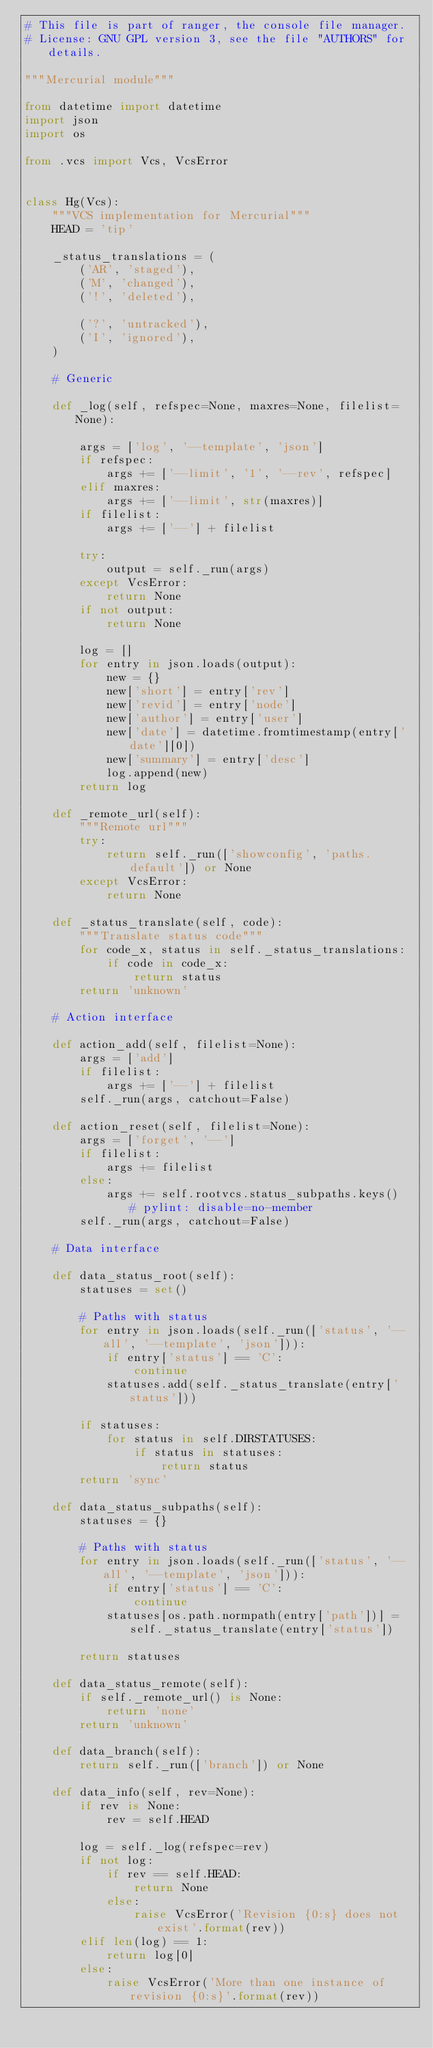Convert code to text. <code><loc_0><loc_0><loc_500><loc_500><_Python_># This file is part of ranger, the console file manager.
# License: GNU GPL version 3, see the file "AUTHORS" for details.

"""Mercurial module"""

from datetime import datetime
import json
import os

from .vcs import Vcs, VcsError


class Hg(Vcs):
    """VCS implementation for Mercurial"""
    HEAD = 'tip'

    _status_translations = (
        ('AR', 'staged'),
        ('M', 'changed'),
        ('!', 'deleted'),

        ('?', 'untracked'),
        ('I', 'ignored'),
    )

    # Generic

    def _log(self, refspec=None, maxres=None, filelist=None):

        args = ['log', '--template', 'json']
        if refspec:
            args += ['--limit', '1', '--rev', refspec]
        elif maxres:
            args += ['--limit', str(maxres)]
        if filelist:
            args += ['--'] + filelist

        try:
            output = self._run(args)
        except VcsError:
            return None
        if not output:
            return None

        log = []
        for entry in json.loads(output):
            new = {}
            new['short'] = entry['rev']
            new['revid'] = entry['node']
            new['author'] = entry['user']
            new['date'] = datetime.fromtimestamp(entry['date'][0])
            new['summary'] = entry['desc']
            log.append(new)
        return log

    def _remote_url(self):
        """Remote url"""
        try:
            return self._run(['showconfig', 'paths.default']) or None
        except VcsError:
            return None

    def _status_translate(self, code):
        """Translate status code"""
        for code_x, status in self._status_translations:
            if code in code_x:
                return status
        return 'unknown'

    # Action interface

    def action_add(self, filelist=None):
        args = ['add']
        if filelist:
            args += ['--'] + filelist
        self._run(args, catchout=False)

    def action_reset(self, filelist=None):
        args = ['forget', '--']
        if filelist:
            args += filelist
        else:
            args += self.rootvcs.status_subpaths.keys()  # pylint: disable=no-member
        self._run(args, catchout=False)

    # Data interface

    def data_status_root(self):
        statuses = set()

        # Paths with status
        for entry in json.loads(self._run(['status', '--all', '--template', 'json'])):
            if entry['status'] == 'C':
                continue
            statuses.add(self._status_translate(entry['status']))

        if statuses:
            for status in self.DIRSTATUSES:
                if status in statuses:
                    return status
        return 'sync'

    def data_status_subpaths(self):
        statuses = {}

        # Paths with status
        for entry in json.loads(self._run(['status', '--all', '--template', 'json'])):
            if entry['status'] == 'C':
                continue
            statuses[os.path.normpath(entry['path'])] = self._status_translate(entry['status'])

        return statuses

    def data_status_remote(self):
        if self._remote_url() is None:
            return 'none'
        return 'unknown'

    def data_branch(self):
        return self._run(['branch']) or None

    def data_info(self, rev=None):
        if rev is None:
            rev = self.HEAD

        log = self._log(refspec=rev)
        if not log:
            if rev == self.HEAD:
                return None
            else:
                raise VcsError('Revision {0:s} does not exist'.format(rev))
        elif len(log) == 1:
            return log[0]
        else:
            raise VcsError('More than one instance of revision {0:s}'.format(rev))
</code> 